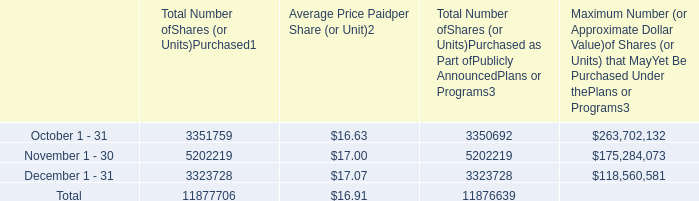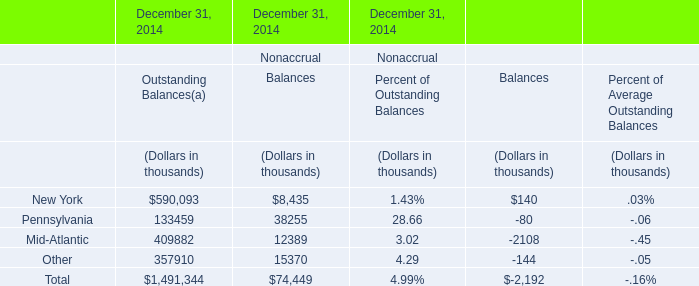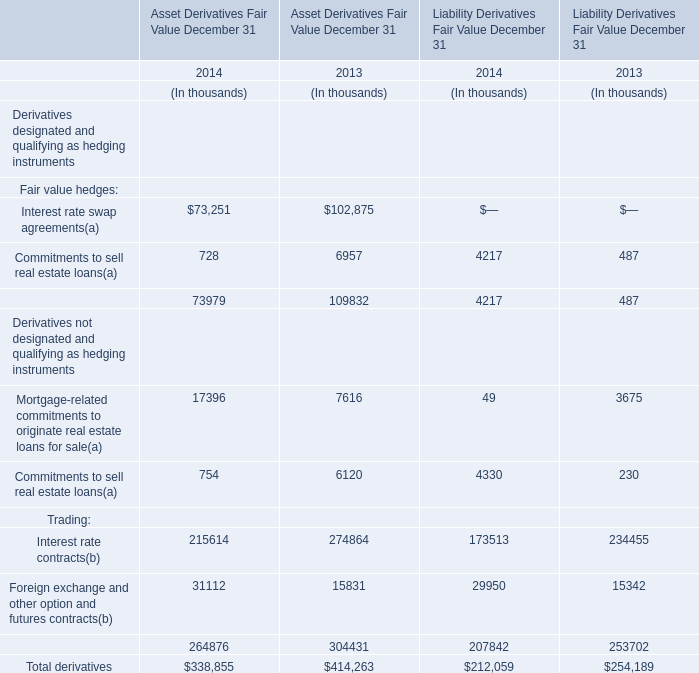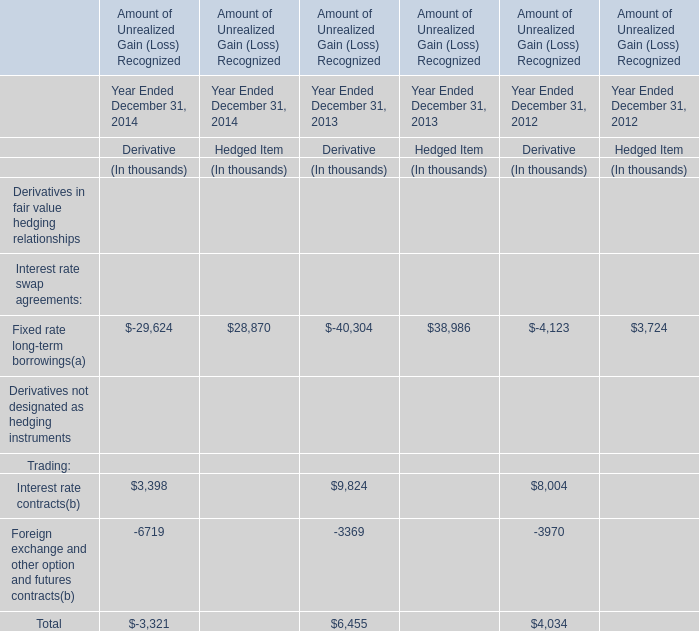Which year does total Asset Derivatives Fair Value rank higher? 
Answer: 2013. 